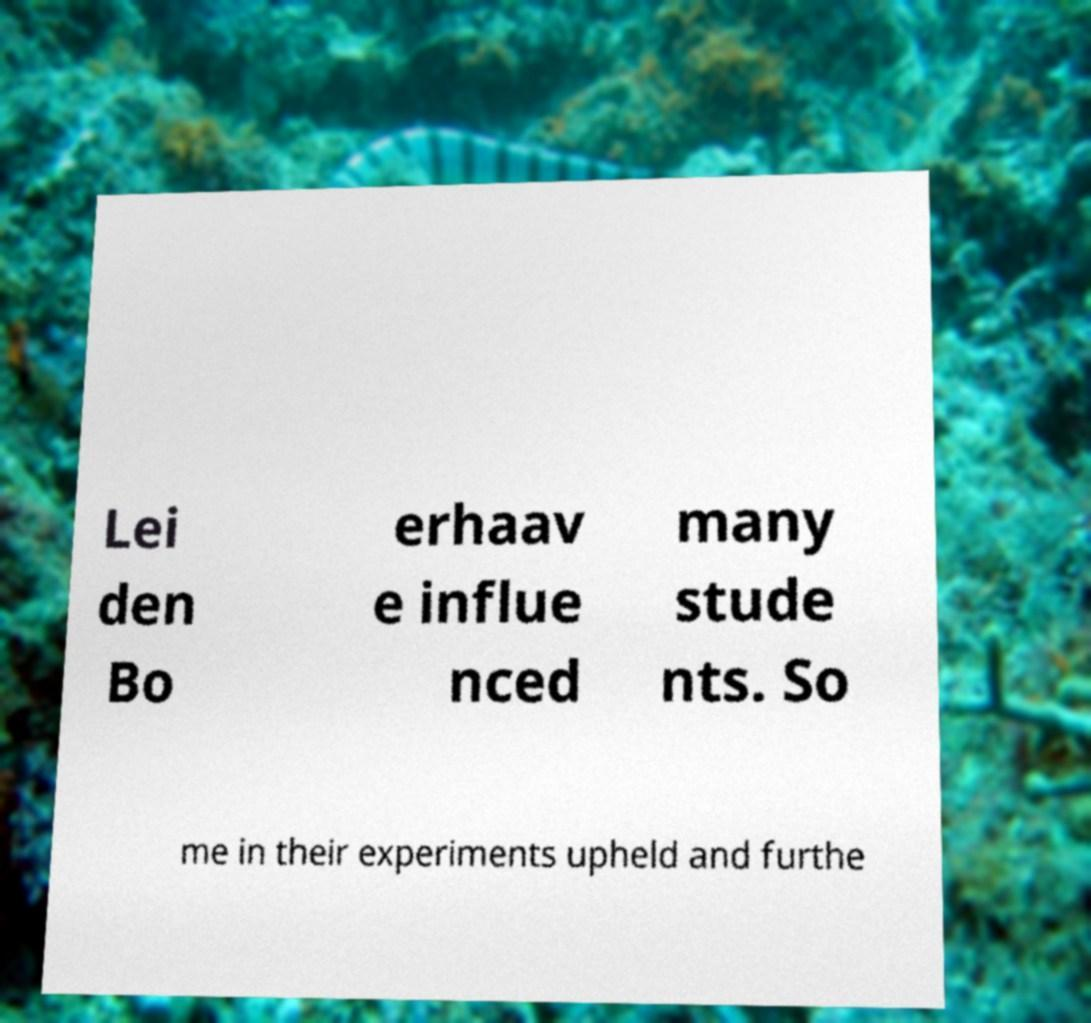There's text embedded in this image that I need extracted. Can you transcribe it verbatim? Lei den Bo erhaav e influe nced many stude nts. So me in their experiments upheld and furthe 